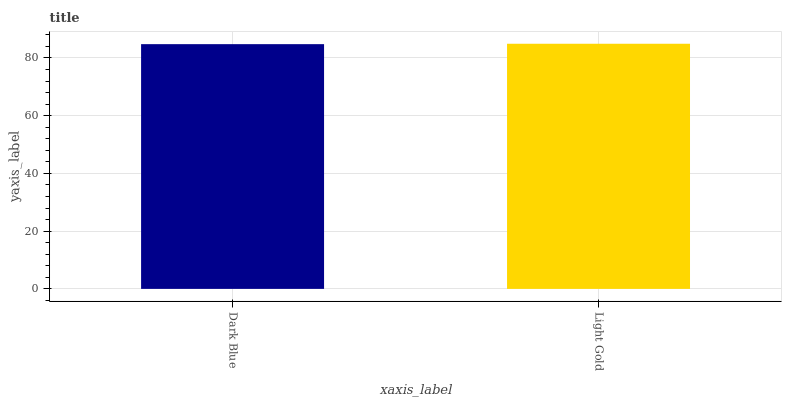Is Dark Blue the minimum?
Answer yes or no. Yes. Is Light Gold the maximum?
Answer yes or no. Yes. Is Light Gold the minimum?
Answer yes or no. No. Is Light Gold greater than Dark Blue?
Answer yes or no. Yes. Is Dark Blue less than Light Gold?
Answer yes or no. Yes. Is Dark Blue greater than Light Gold?
Answer yes or no. No. Is Light Gold less than Dark Blue?
Answer yes or no. No. Is Light Gold the high median?
Answer yes or no. Yes. Is Dark Blue the low median?
Answer yes or no. Yes. Is Dark Blue the high median?
Answer yes or no. No. Is Light Gold the low median?
Answer yes or no. No. 